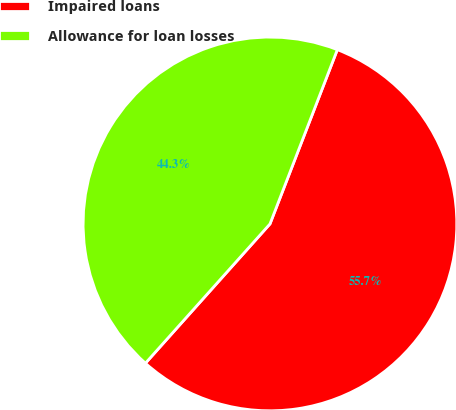Convert chart. <chart><loc_0><loc_0><loc_500><loc_500><pie_chart><fcel>Impaired loans<fcel>Allowance for loan losses<nl><fcel>55.74%<fcel>44.26%<nl></chart> 